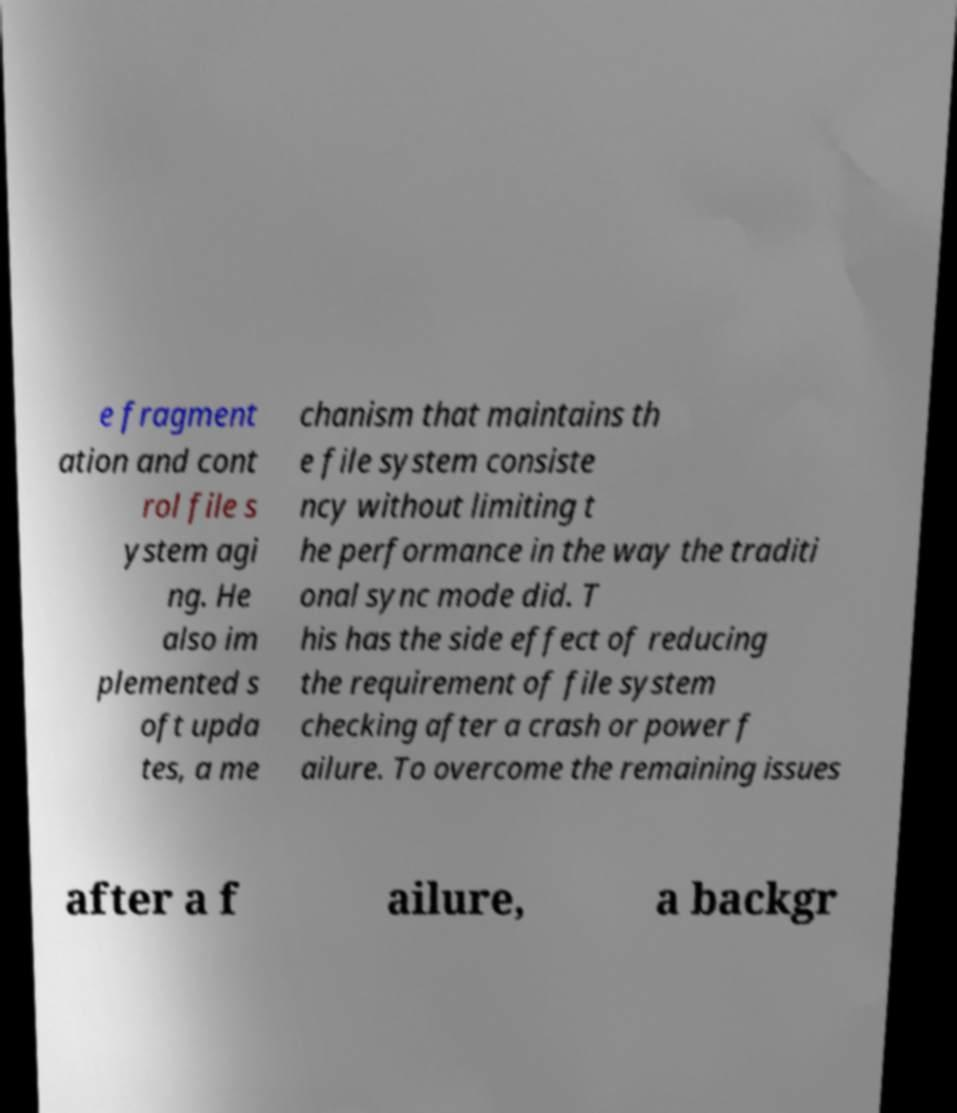Can you read and provide the text displayed in the image?This photo seems to have some interesting text. Can you extract and type it out for me? e fragment ation and cont rol file s ystem agi ng. He also im plemented s oft upda tes, a me chanism that maintains th e file system consiste ncy without limiting t he performance in the way the traditi onal sync mode did. T his has the side effect of reducing the requirement of file system checking after a crash or power f ailure. To overcome the remaining issues after a f ailure, a backgr 